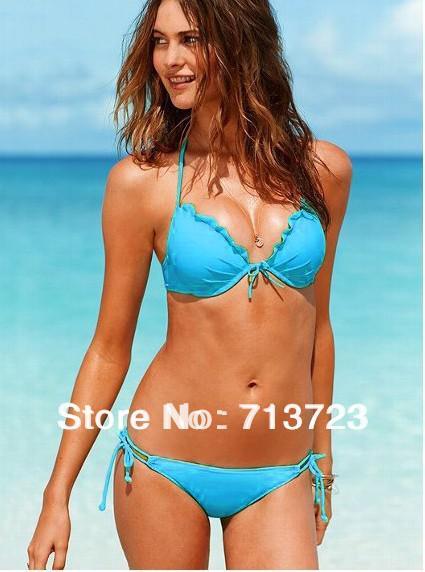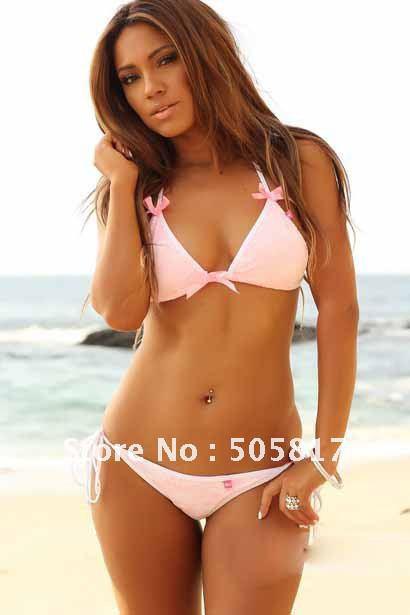The first image is the image on the left, the second image is the image on the right. For the images shown, is this caption "An image shows a rear view of a bikini and a forward view." true? Answer yes or no. No. 